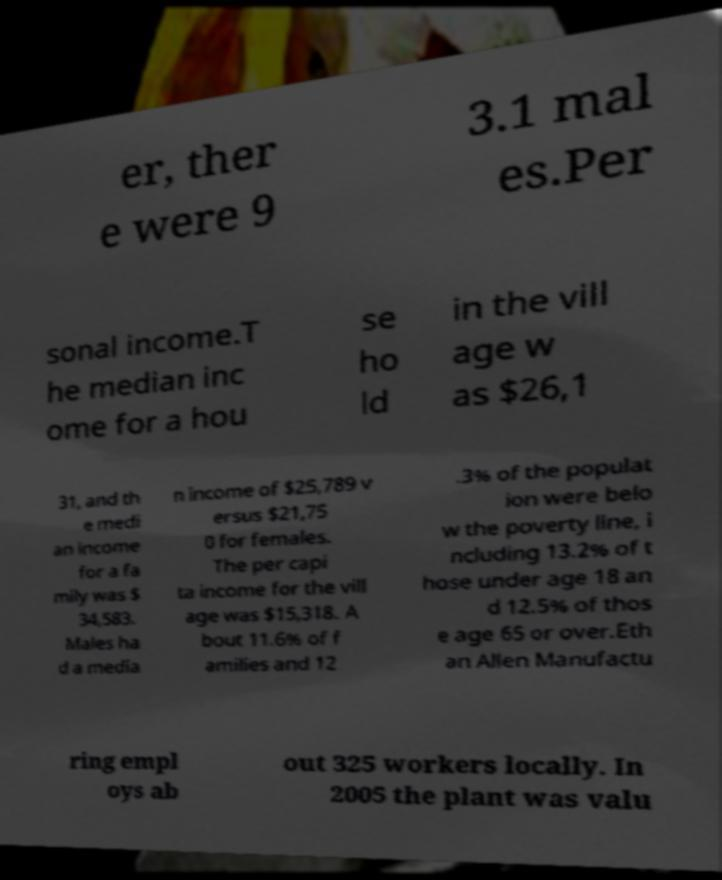Could you assist in decoding the text presented in this image and type it out clearly? er, ther e were 9 3.1 mal es.Per sonal income.T he median inc ome for a hou se ho ld in the vill age w as $26,1 31, and th e medi an income for a fa mily was $ 34,583. Males ha d a media n income of $25,789 v ersus $21,75 0 for females. The per capi ta income for the vill age was $15,318. A bout 11.6% of f amilies and 12 .3% of the populat ion were belo w the poverty line, i ncluding 13.2% of t hose under age 18 an d 12.5% of thos e age 65 or over.Eth an Allen Manufactu ring empl oys ab out 325 workers locally. In 2005 the plant was valu 